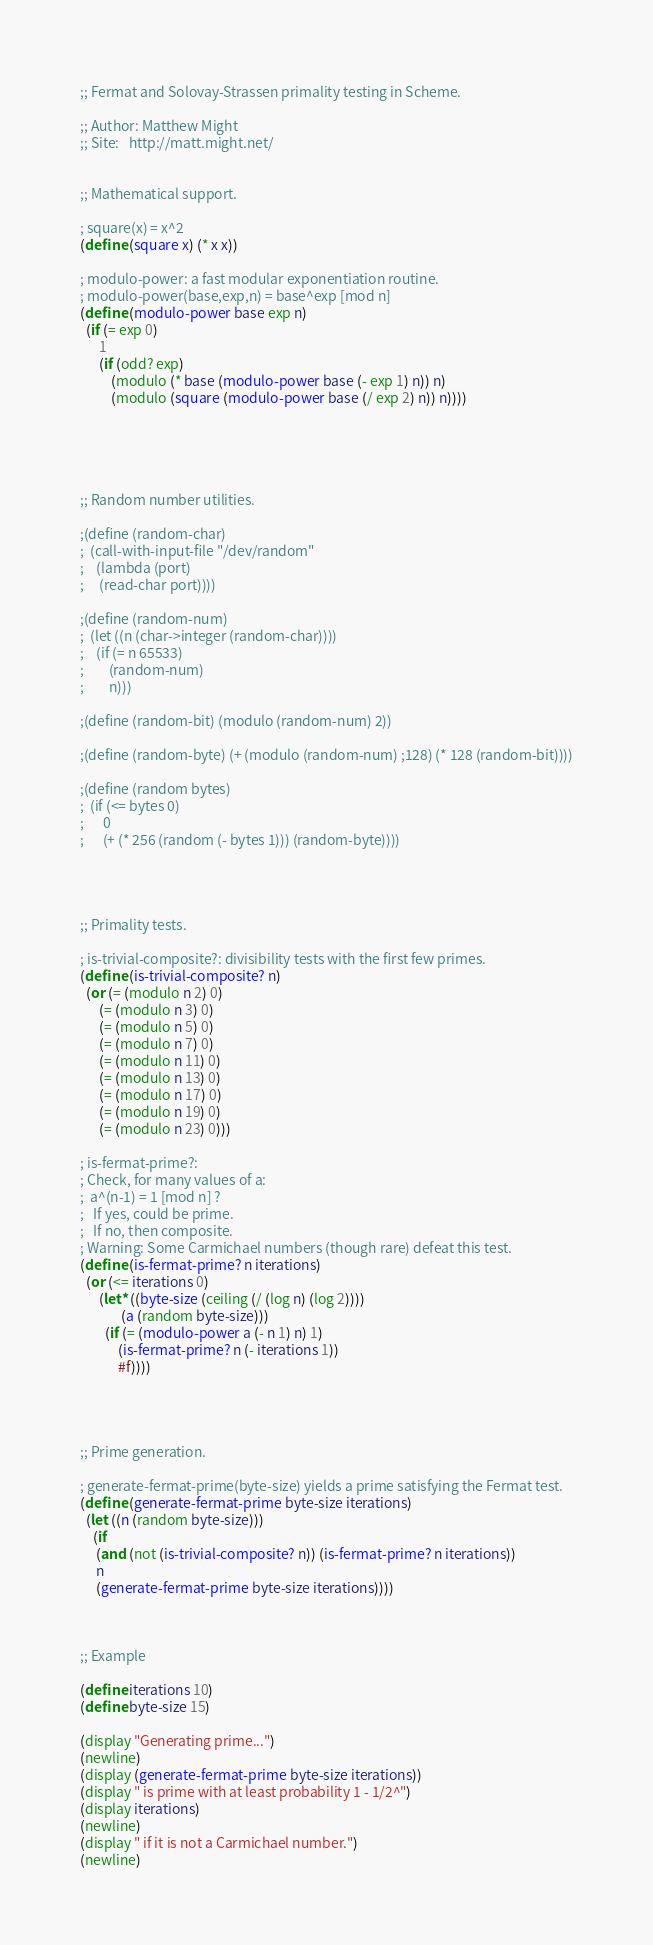<code> <loc_0><loc_0><loc_500><loc_500><_Scheme_>;; Fermat and Solovay-Strassen primality testing in Scheme.

;; Author: Matthew Might
;; Site:   http://matt.might.net/


;; Mathematical support.

; square(x) = x^2
(define (square x) (* x x))

; modulo-power: a fast modular exponentiation routine.
; modulo-power(base,exp,n) = base^exp [mod n]
(define (modulo-power base exp n)
  (if (= exp 0)
      1
      (if (odd? exp)
          (modulo (* base (modulo-power base (- exp 1) n)) n)
          (modulo (square (modulo-power base (/ exp 2) n)) n))))

                     
    


;; Random number utilities.

;(define (random-char) 
;  (call-with-input-file "/dev/random" 
;    (lambda (port)
;     (read-char port))))

;(define (random-num)
;  (let ((n (char->integer (random-char))))
;    (if (= n 65533)
;        (random-num)
;        n)))

;(define (random-bit) (modulo (random-num) 2))

;(define (random-byte) (+ (modulo (random-num) ;128) (* 128 (random-bit))))

;(define (random bytes)
;  (if (<= bytes 0)
;      0
;      (+ (* 256 (random (- bytes 1))) (random-byte))))




;; Primality tests.

; is-trivial-composite?: divisibility tests with the first few primes.
(define (is-trivial-composite? n)
  (or (= (modulo n 2) 0)
      (= (modulo n 3) 0)
      (= (modulo n 5) 0)
      (= (modulo n 7) 0)
      (= (modulo n 11) 0)
      (= (modulo n 13) 0)
      (= (modulo n 17) 0)
      (= (modulo n 19) 0)
      (= (modulo n 23) 0)))

; is-fermat-prime?:
; Check, for many values of a:
;  a^(n-1) = 1 [mod n] ?  
;   If yes, could be prime.  
;   If no, then composite.
; Warning: Some Carmichael numbers (though rare) defeat this test.
(define (is-fermat-prime? n iterations)
  (or (<= iterations 0)
      (let* ((byte-size (ceiling (/ (log n) (log 2))))
             (a (random byte-size)))
        (if (= (modulo-power a (- n 1) n) 1)
            (is-fermat-prime? n (- iterations 1))
            #f))))



      
;; Prime generation.

; generate-fermat-prime(byte-size) yields a prime satisfying the Fermat test.
(define (generate-fermat-prime byte-size iterations)
  (let ((n (random byte-size)))
    (if
     (and (not (is-trivial-composite? n)) (is-fermat-prime? n iterations))
     n
     (generate-fermat-prime byte-size iterations))))



;; Example

(define iterations 10)
(define byte-size 15)

(display "Generating prime...") 
(newline)
(display (generate-fermat-prime byte-size iterations)) 
(display " is prime with at least probability 1 - 1/2^")
(display iterations)
(newline)
(display " if it is not a Carmichael number.")
(newline)
</code> 